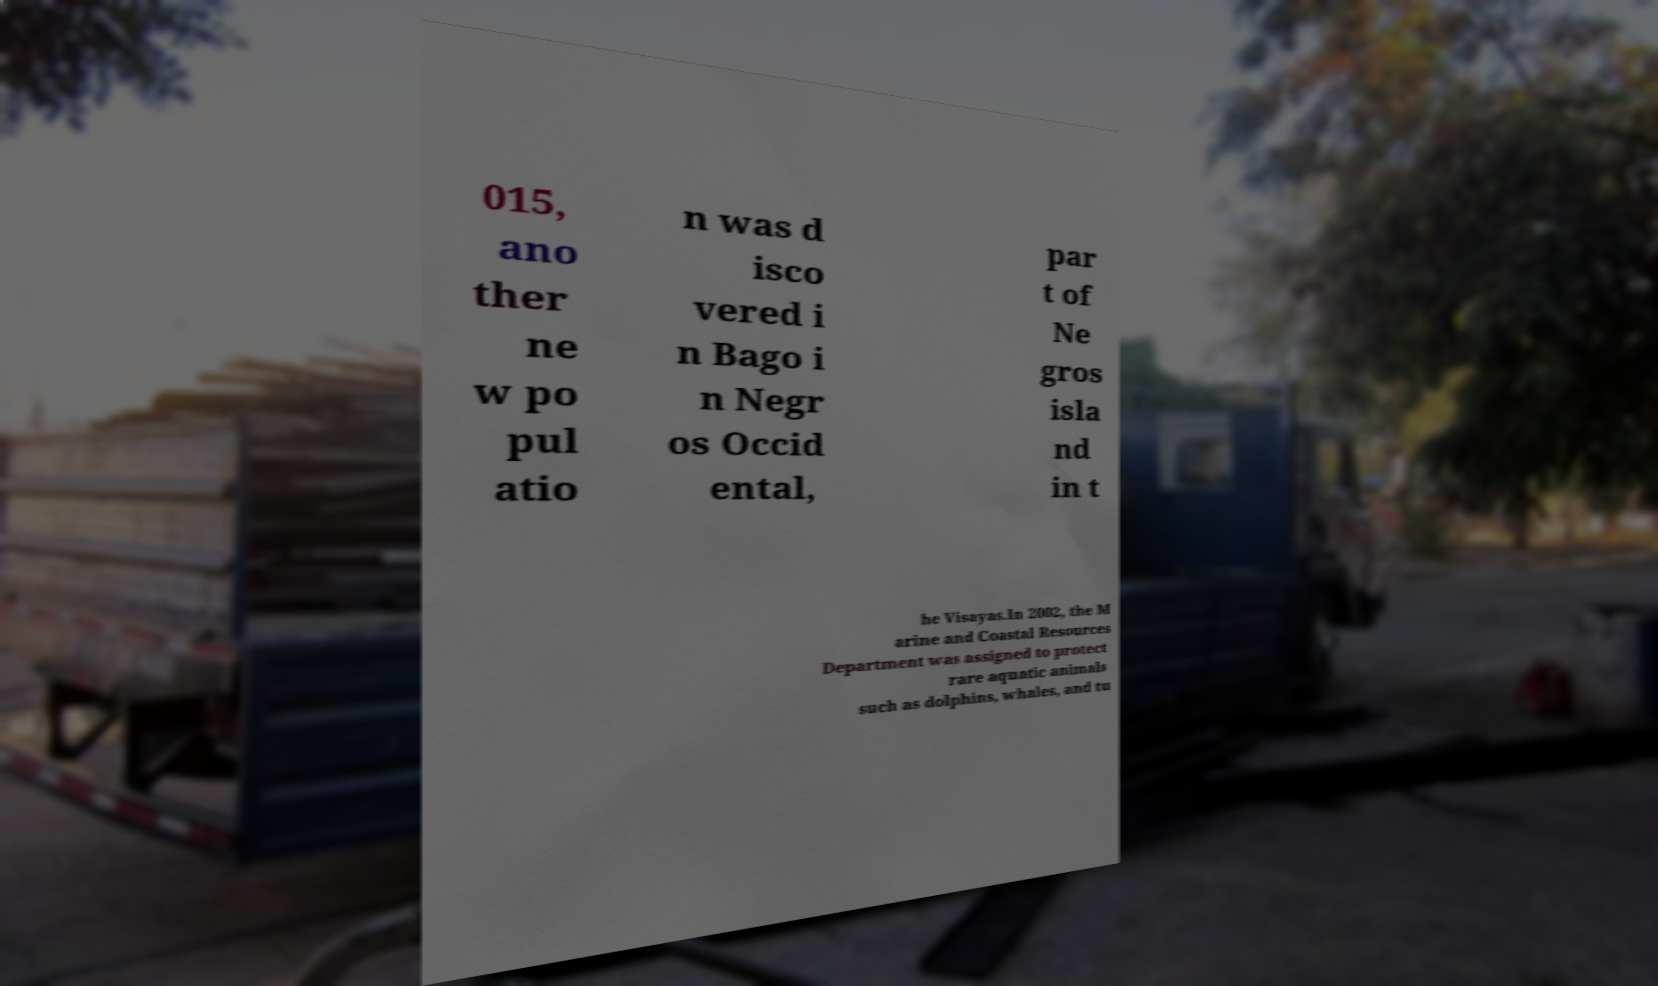Please identify and transcribe the text found in this image. 015, ano ther ne w po pul atio n was d isco vered i n Bago i n Negr os Occid ental, par t of Ne gros isla nd in t he Visayas.In 2002, the M arine and Coastal Resources Department was assigned to protect rare aquatic animals such as dolphins, whales, and tu 